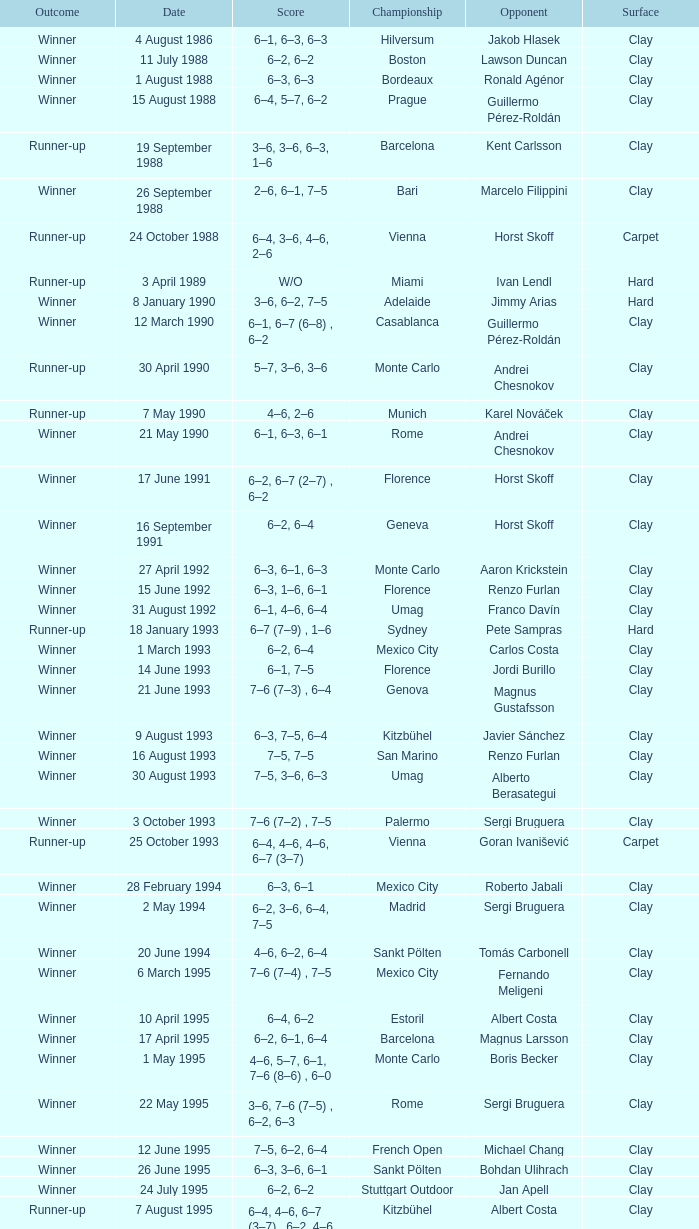Who is the opponent on 18 january 1993? Pete Sampras. 